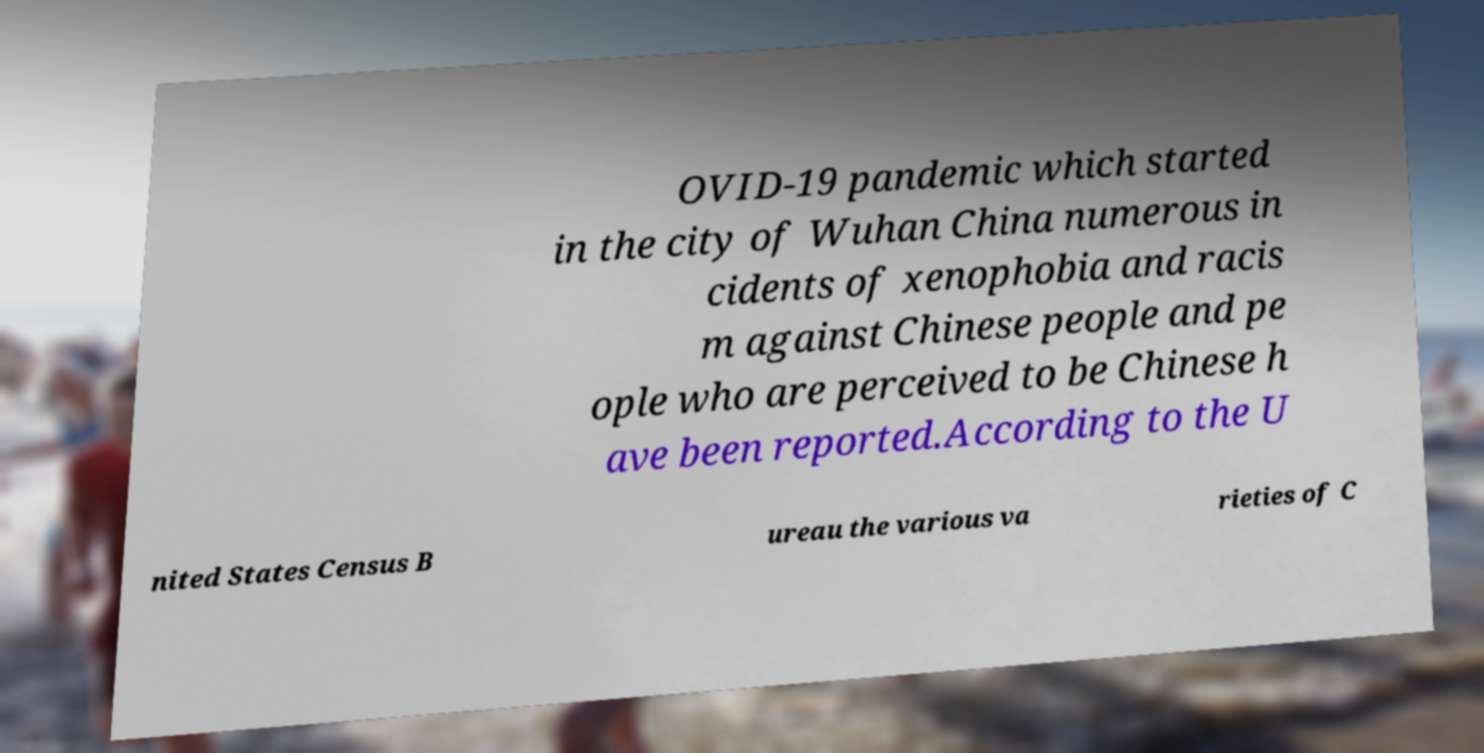What messages or text are displayed in this image? I need them in a readable, typed format. OVID-19 pandemic which started in the city of Wuhan China numerous in cidents of xenophobia and racis m against Chinese people and pe ople who are perceived to be Chinese h ave been reported.According to the U nited States Census B ureau the various va rieties of C 